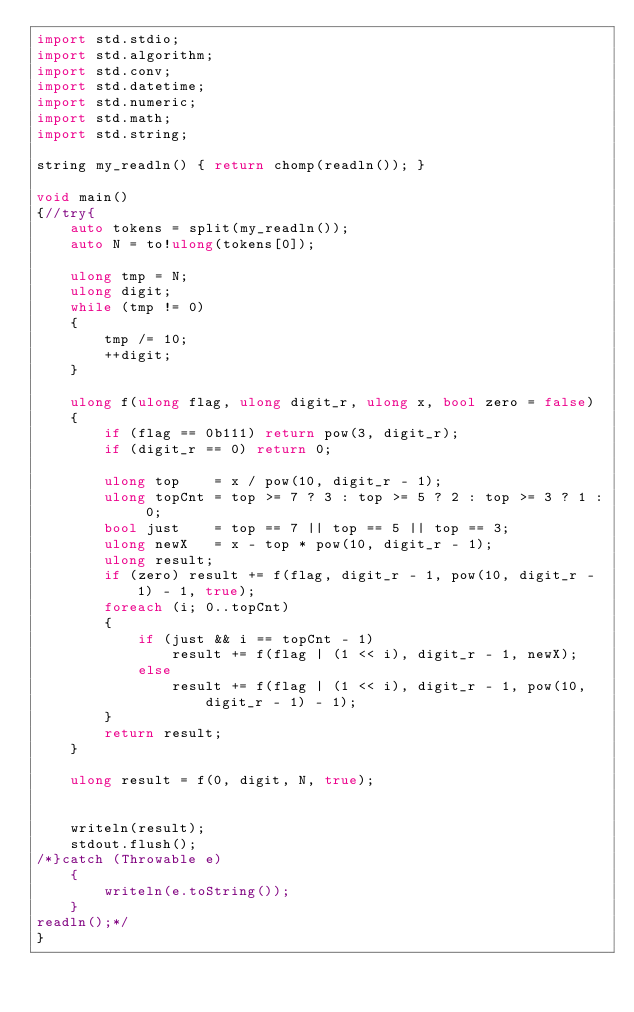Convert code to text. <code><loc_0><loc_0><loc_500><loc_500><_D_>import std.stdio;
import std.algorithm;
import std.conv;
import std.datetime;
import std.numeric;
import std.math;
import std.string;

string my_readln() { return chomp(readln()); }

void main()
{//try{
	auto tokens = split(my_readln());
	auto N = to!ulong(tokens[0]);

	ulong tmp = N;
	ulong digit;
	while (tmp != 0)
	{
		tmp /= 10;
		++digit;
	}
	
	ulong f(ulong flag, ulong digit_r, ulong x, bool zero = false)
	{
		if (flag == 0b111) return pow(3, digit_r);
		if (digit_r == 0) return 0;

		ulong top    = x / pow(10, digit_r - 1);
		ulong topCnt = top >= 7 ? 3 : top >= 5 ? 2 : top >= 3 ? 1 : 0;
		bool just    = top == 7 || top == 5 || top == 3;
		ulong newX   = x - top * pow(10, digit_r - 1);
		ulong result;
		if (zero) result += f(flag, digit_r - 1, pow(10, digit_r - 1) - 1, true);
		foreach (i; 0..topCnt)
		{
			if (just && i == topCnt - 1)
				result += f(flag | (1 << i), digit_r - 1, newX);
			else
				result += f(flag | (1 << i), digit_r - 1, pow(10, digit_r - 1) - 1);
		}
		return result;
	}

	ulong result = f(0, digit, N, true);
	

	writeln(result);
	stdout.flush();
/*}catch (Throwable e)
	{
		writeln(e.toString());
	}
readln();*/
}</code> 